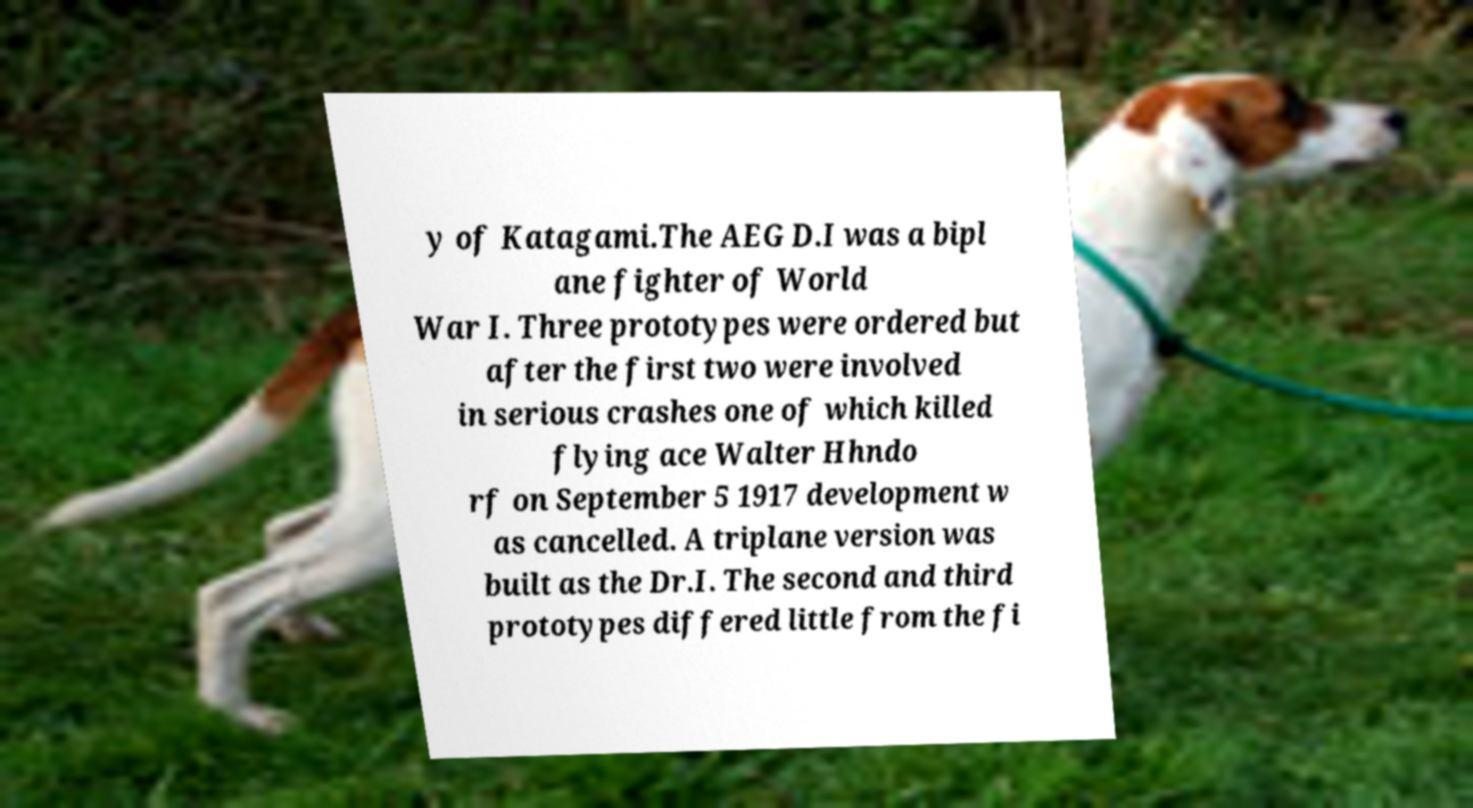Can you accurately transcribe the text from the provided image for me? y of Katagami.The AEG D.I was a bipl ane fighter of World War I. Three prototypes were ordered but after the first two were involved in serious crashes one of which killed flying ace Walter Hhndo rf on September 5 1917 development w as cancelled. A triplane version was built as the Dr.I. The second and third prototypes differed little from the fi 